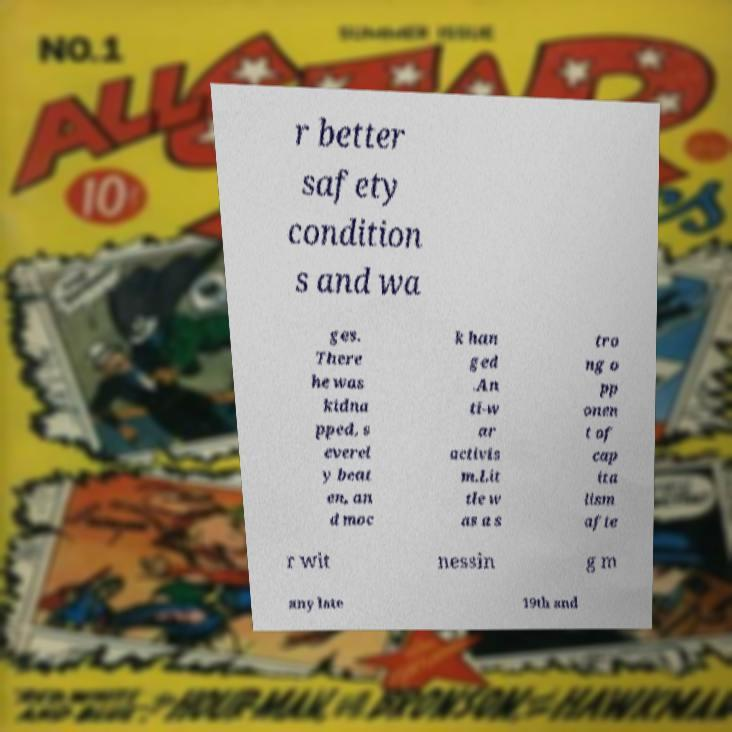Could you extract and type out the text from this image? r better safety condition s and wa ges. There he was kidna pped, s everel y beat en, an d moc k han ged .An ti-w ar activis m.Lit tle w as a s tro ng o pp onen t of cap ita lism afte r wit nessin g m any late 19th and 